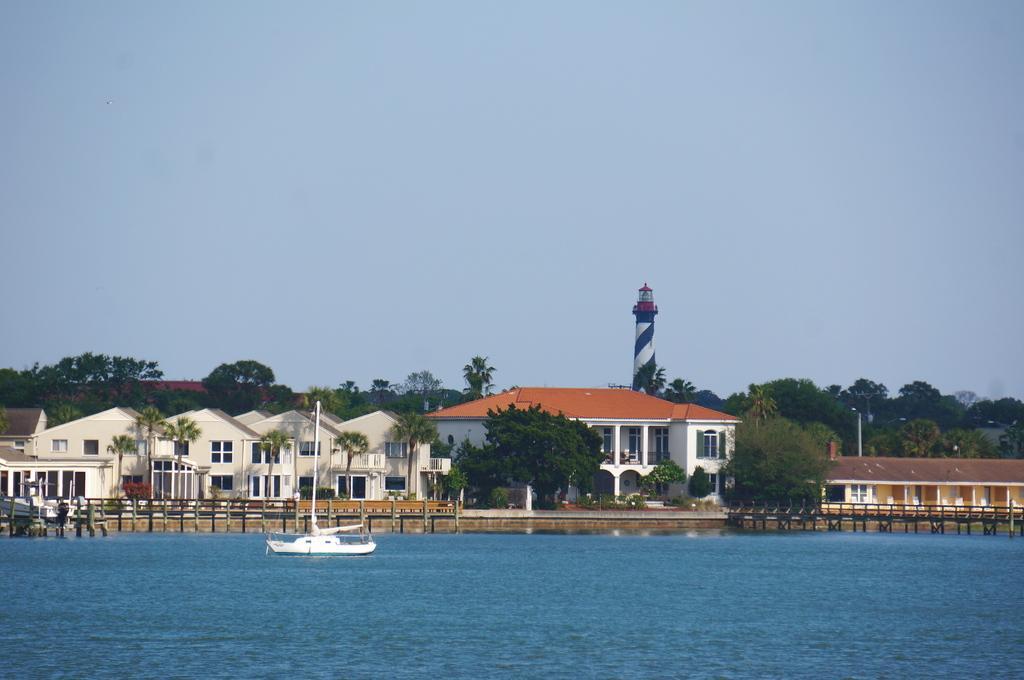Could you give a brief overview of what you see in this image? In this image we can see buildings, here is the window, here are the trees, here is the boat, here is the water, here is the tower, at above here is the sky in blue color. 